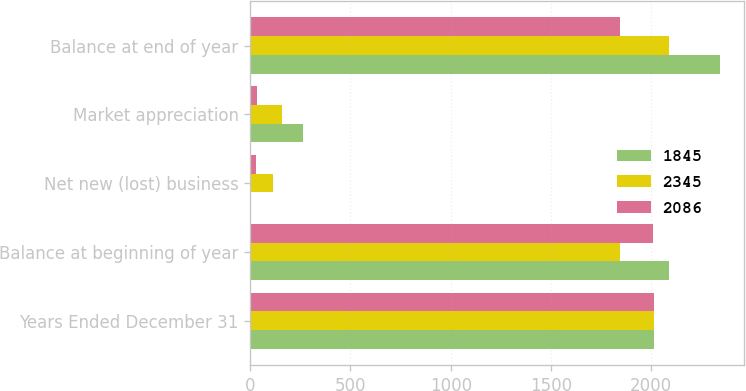<chart> <loc_0><loc_0><loc_500><loc_500><stacked_bar_chart><ecel><fcel>Years Ended December 31<fcel>Balance at beginning of year<fcel>Net new (lost) business<fcel>Market appreciation<fcel>Balance at end of year<nl><fcel>1845<fcel>2013<fcel>2086<fcel>5<fcel>264<fcel>2345<nl><fcel>2345<fcel>2012<fcel>1845<fcel>112<fcel>160<fcel>2086<nl><fcel>2086<fcel>2011<fcel>2010<fcel>30<fcel>33<fcel>1845<nl></chart> 